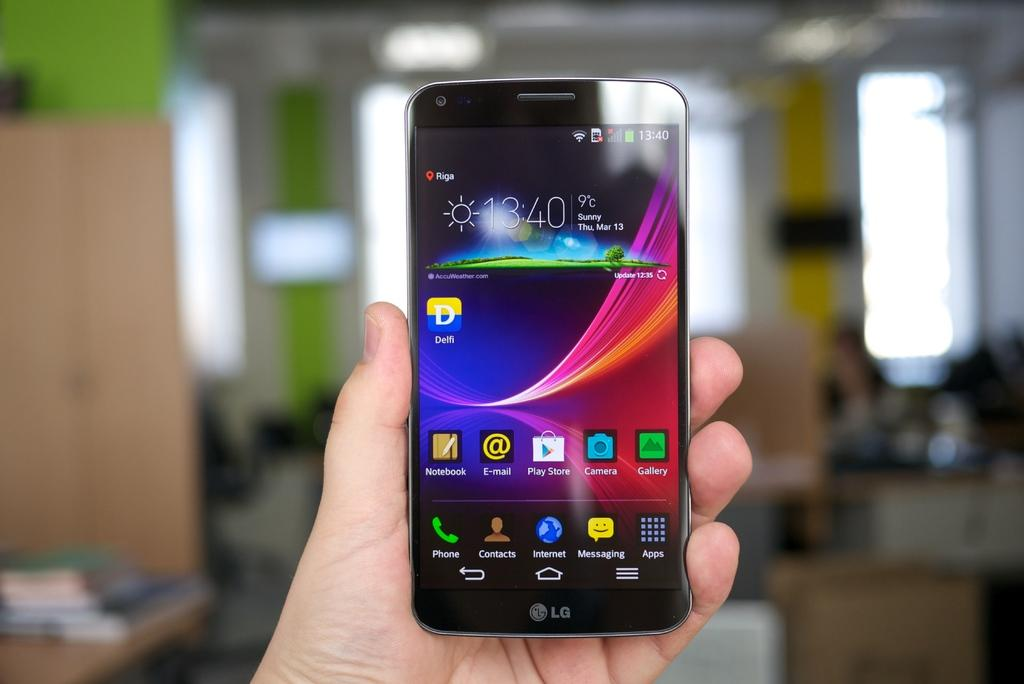<image>
Give a short and clear explanation of the subsequent image. An LG phone being held in the library with the time at 13:40 on March 13th 